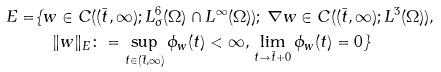Convert formula to latex. <formula><loc_0><loc_0><loc_500><loc_500>E = & \{ w \in C ( ( \bar { t } , \infty ) ; L ^ { 6 } _ { \sigma } ( \Omega ) \cap L ^ { \infty } ( \Omega ) ) ; \, \nabla w \in C ( ( \bar { t } , \infty ) ; L ^ { 3 } ( \Omega ) ) , \\ & \quad \| w \| _ { E } \colon = \sup _ { t \in ( \bar { t } , \infty ) } \phi _ { w } ( t ) < \infty , \, \lim _ { t \to \bar { t } + 0 } \phi _ { w } ( t ) = 0 \}</formula> 